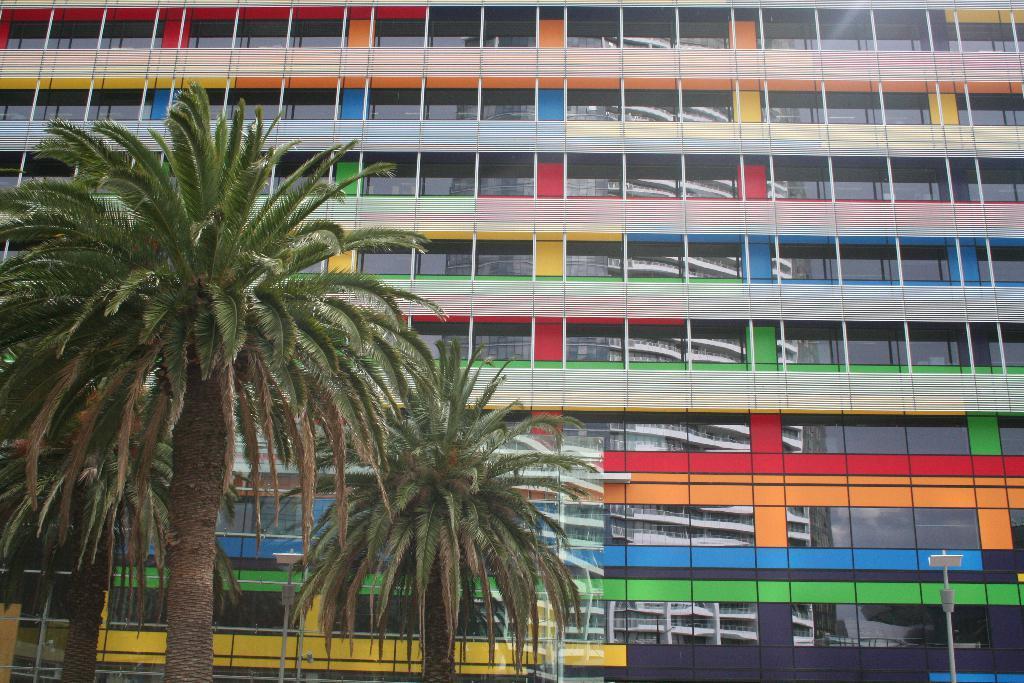Could you give a brief overview of what you see in this image? In this picture we can see a few trees. We can see glass objects and a few things on the building. There are the reflections of some objects on the building. We can see other objects. 